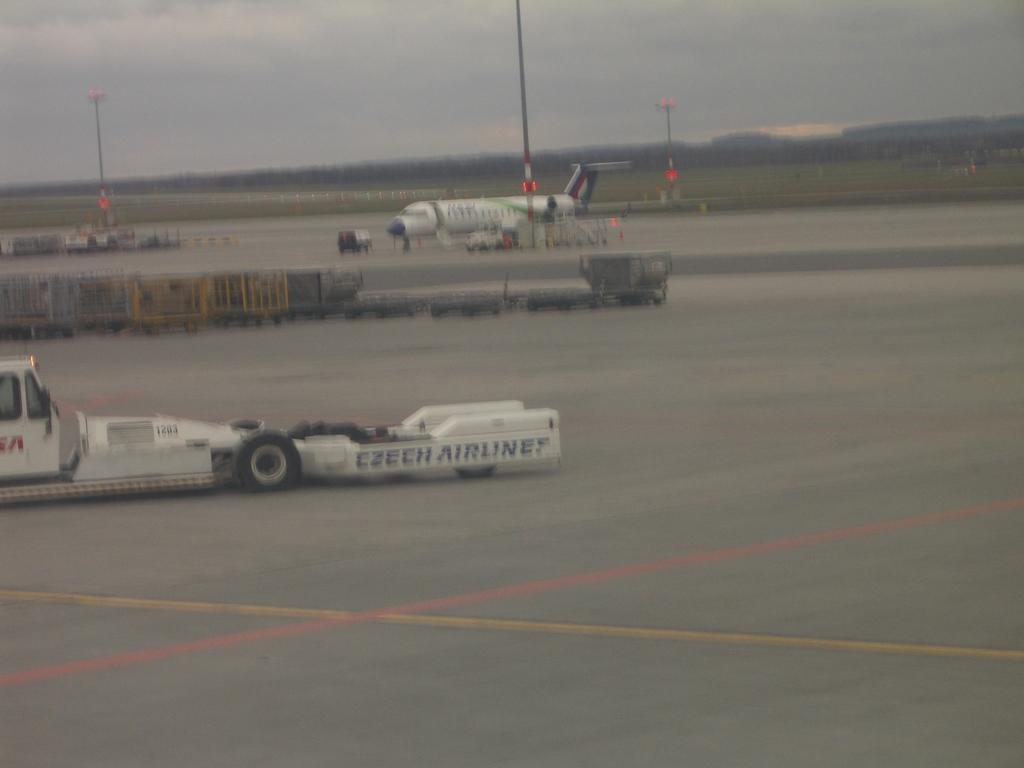What is located in the center of the image? There are vehicles and an airplane in the center of the image. What can be seen in the background of the image? The sky, clouds, poles, and other objects are visible in the background of the image. How many types of transportation are present in the image? There are two types of transportation present in the image: vehicles and an airplane. What is the weather like in the image? The presence of clouds in the background suggests that the weather might be partly cloudy. What type of orange can be seen in the image? There is no orange present in the image. Can you describe the activity of the bee in the image? There is no bee present in the image, so it's not possible to describe any activity. 